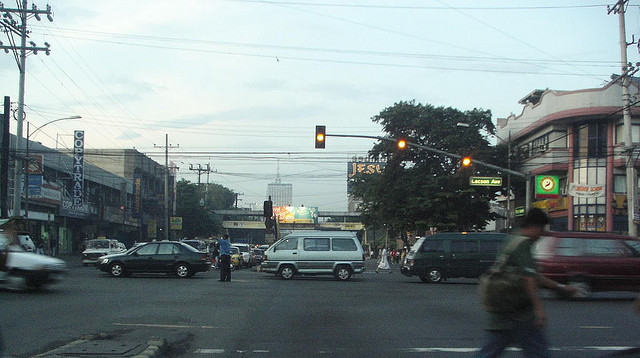Read all the text in this image. COPYTRADE 